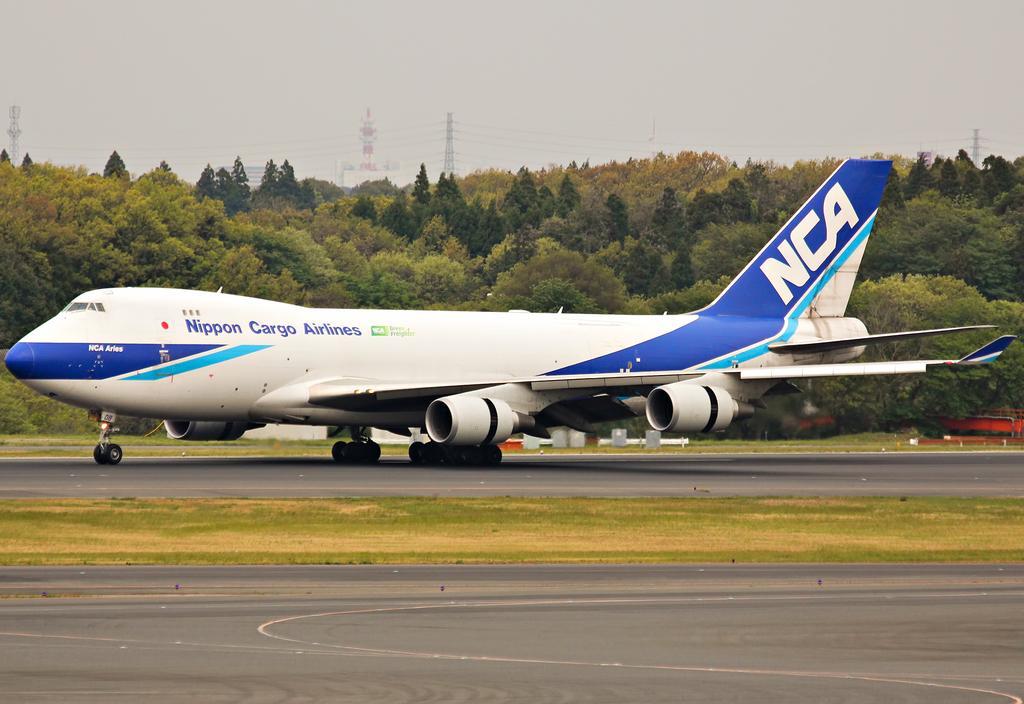In one or two sentences, can you explain what this image depicts? In the image there is an aircraft on the land and in the background there are trees and towers. 